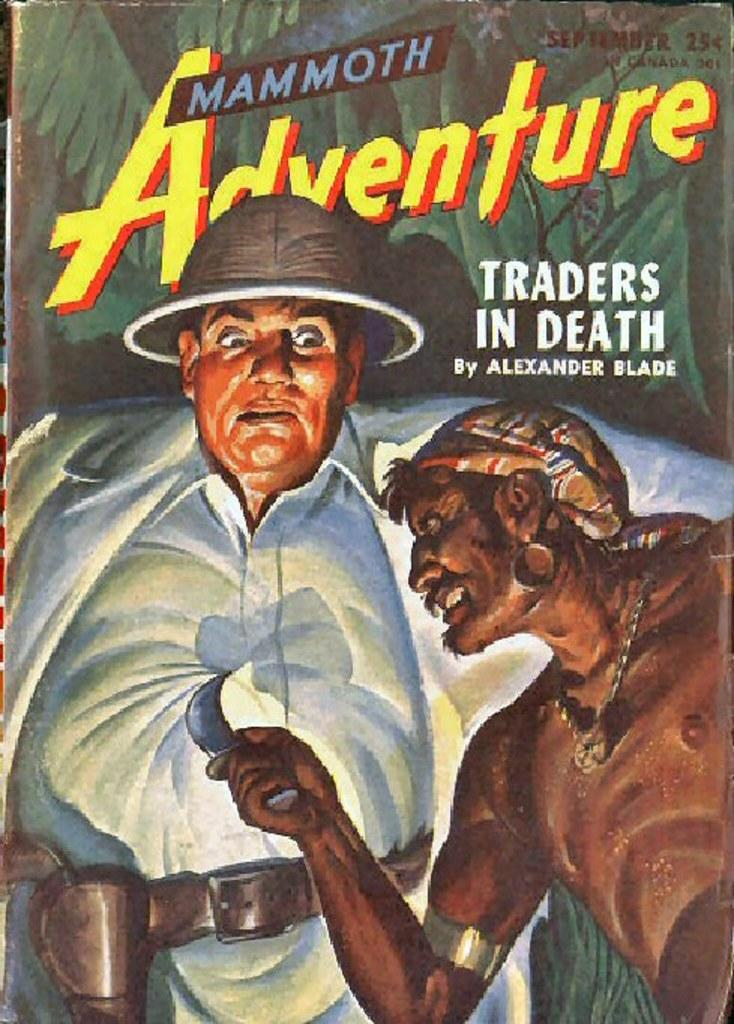What is the main subject of the image? The main subject of the image is a book. What can be seen on the book? There is a painting of people on the book. Is there any text on the book? Yes, there is text on the book. How many pies are being served in the morning in the image? There are no pies or morning scenes present in the image; it is a book with a painting of people and text. 